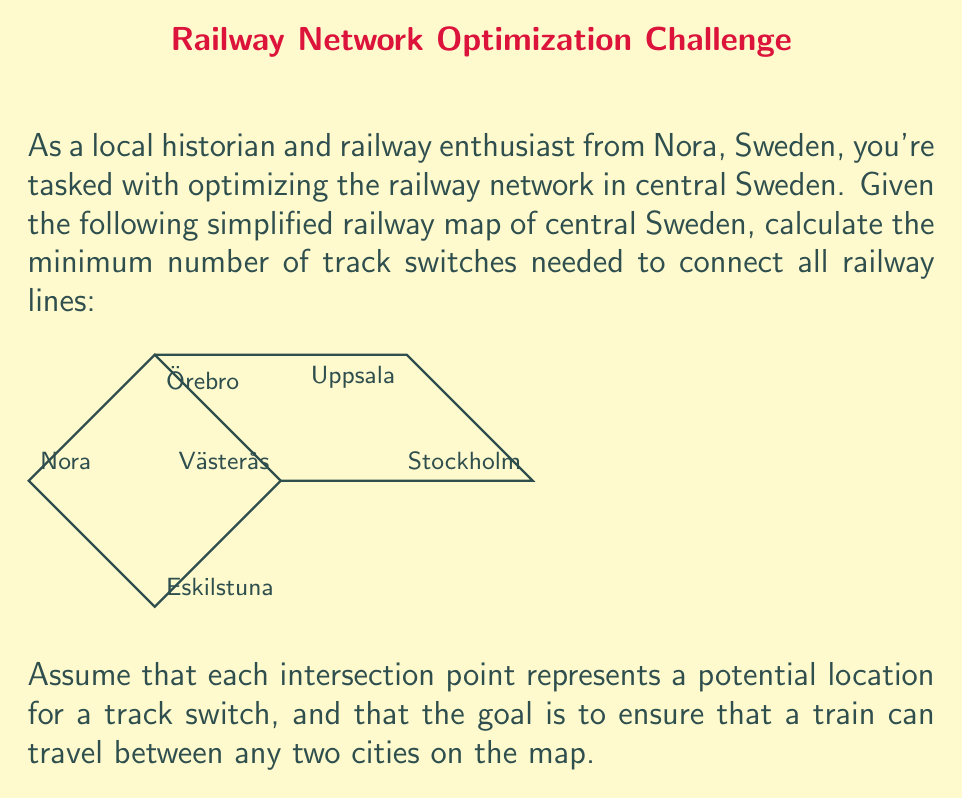Show me your answer to this math problem. To solve this problem, we can use concepts from graph theory, specifically the idea of a minimum spanning tree.

Step 1: Identify the graph structure
The railway map can be represented as an undirected graph $G = (V, E)$, where:
- $V$ (vertices) represent the cities: Nora, Örebro, Västerås, Eskilstuna, Uppsala, and Stockholm
- $E$ (edges) represent the railway lines connecting these cities

Step 2: Count the number of vertices and edges
- Number of vertices: $|V| = 6$
- Number of edges: $|E| = 7$

Step 3: Determine the minimum number of edges needed
To connect all cities with the minimum number of track switches, we need to find a minimum spanning tree of the graph. A minimum spanning tree of a graph with $n$ vertices always has $n-1$ edges.

Therefore, the minimum number of edges needed = $|V| - 1 = 6 - 1 = 5$

Step 4: Calculate the number of track switches needed
The number of track switches needed is the difference between the total number of edges and the minimum number of edges required:

Number of track switches = $|E| - (|V| - 1) = 7 - 5 = 2$

This means we need to remove 2 edges (railway lines) from the original graph to create a minimum spanning tree, which requires 2 track switches to be installed at the appropriate intersections.
Answer: 2 track switches 